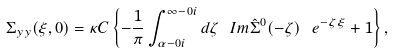<formula> <loc_0><loc_0><loc_500><loc_500>\Sigma _ { y y } ( \xi , 0 ) = \kappa C \left \{ - \frac { 1 } { \pi } \int _ { \alpha - 0 i } ^ { \infty - 0 i } d \zeta \ I m \hat { \Sigma } ^ { 0 } ( - \zeta ) \ e ^ { - \zeta \xi } + 1 \right \} ,</formula> 